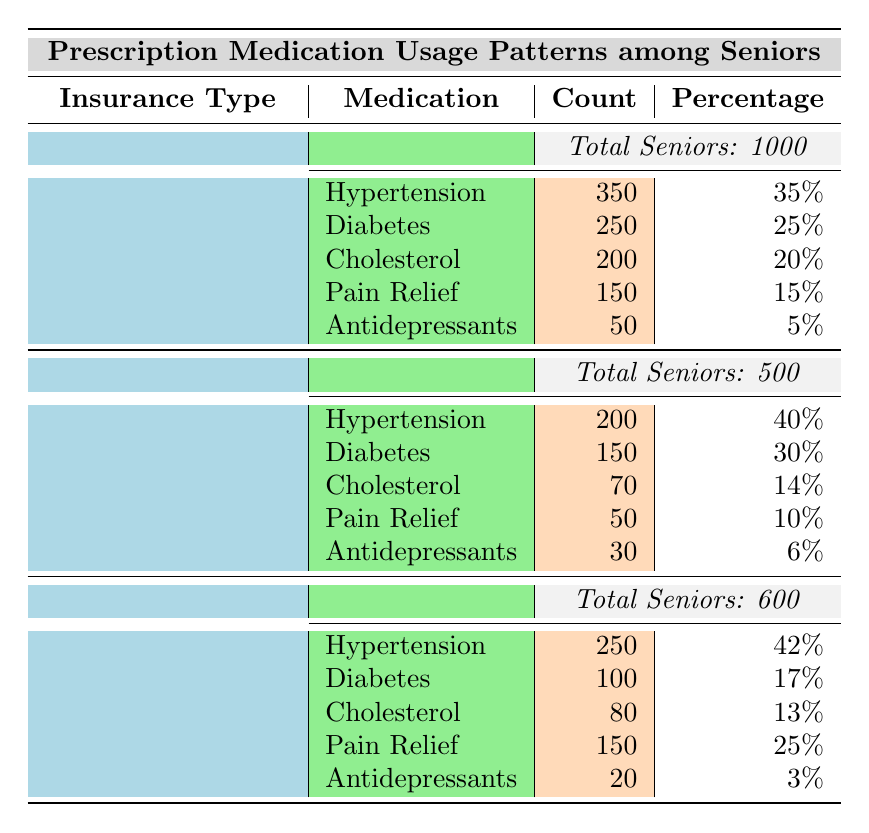What is the total number of seniors with Medicare insurance? The table indicates that there are 1000 seniors who have Medicare insurance in the prescribed medication usage patterns section.
Answer: 1000 Which medication is most commonly used among seniors with Medicaid? According to the table, the most commonly used medication among seniors with Medicaid is Hypertension, with a count of 200.
Answer: Hypertension What percentage of seniors with Private Insurance are using Pain Relief medications? The table shows that 150 seniors with Private Insurance are using Pain Relief medications, which is 25% of the total 600 seniors covered under this insurance type.
Answer: 25% True or False: More seniors with Medicaid use Antidepressants than those with Private Insurance. The table shows that 30 seniors with Medicaid use Antidepressants, while only 20 seniors with Private Insurance do, which means the statement is true.
Answer: True What is the combined total count of seniors who use Diabetes medication across all insurance types? To find the combined total, sum the count of seniors using Diabetes medication: 250 (Medicare) + 150 (Medicaid) + 100 (Private Insurance) = 500.
Answer: 500 Which insurance type has the highest percentage of seniors using Cholesterol medications? Looking at the table, Medicare has 20%, Medicaid has 14%, and Private Insurance has 13%. Therefore, Medicare has the highest percentage.
Answer: Medicare What is the total number of seniors using Hypertension medication across all insurance types? Adding the counts: 350 (Medicare) + 200 (Medicaid) + 250 (Private Insurance) gives a total of 800 seniors using Hypertension medications.
Answer: 800 Is the total number of seniors using Pain Relief medications higher in Medicare than in Medicaid? The table shows that 150 seniors with Medicare use Pain Relief medications, while 50 seniors with Medicaid do. Since 150 is greater than 50, the statement is true.
Answer: True What is the average percentage of seniors using Antidepressants across all insurance types? Calculate the average by adding the percentages: 5% (Medicare) + 6% (Medicaid) + 3% (Private Insurance) = 14%. Dividing by 3 gives an average of about 4.67%.
Answer: 4.67% 